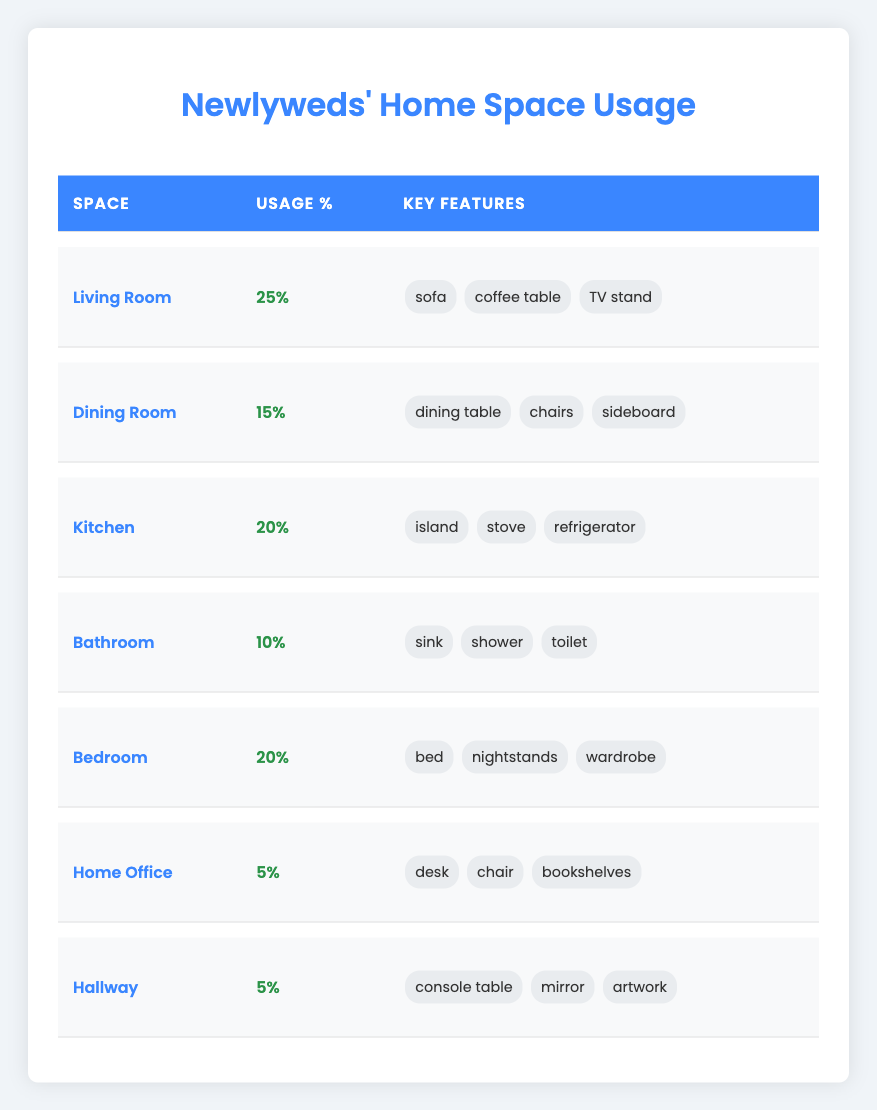What is the percentage of space usage in the Living Room? According to the table, the usage percentage for the Living Room is listed as 25%.
Answer: 25% Is the Dining Room space usage greater than the Home Office's? The Dining Room usage percentage is 15%, while the Home Office is only 5%. Since 15% is greater than 5%, the statement is true.
Answer: Yes What are the key features of the Bedroom? The table shows that the Bedroom includes key features such as a bed, nightstands, and a wardrobe.
Answer: Bed, nightstands, wardrobe What is the total percentage of space usage in common areas (Living Room, Dining Room, Kitchen) versus private spaces (Bedroom, Bathroom, Home Office)? The common areas usage is 25% + 15% + 20% = 60%. The private spaces usage is 20% + 10% + 5% = 35%. Comparing these totals, common areas usage is greater than private spaces.
Answer: Common areas: 60%, Private spaces: 35% Which room has the least space usage? By reviewing the percentages in the table, both the Home Office and Hallway have the lowest usage, each at 5%.
Answer: Home Office and Hallway If we combine the usage percentages of the Kitchen and Bathroom, what will that total be? The table shows the Kitchen at 20% and the Bathroom at 10%. Adding these together gives 20% + 10% = 30%.
Answer: 30% Is there any space with an exactly 20% usage percentage? The Bedroom and Kitchen both have a usage percentage of 20%. Therefore, the answer is yes.
Answer: Yes What is the percentage difference between the space usage of the Living Room and the Bathroom? The Living Room usage is 25% and the Bathroom is 10%. The difference is 25% - 10% = 15%.
Answer: 15% If you were to prioritize common spaces based on usage percentage, which three spaces would you focus on? The three common spaces with the highest usage percentages are the Living Room (25%), Kitchen (20%), and Dining Room (15%).
Answer: Living Room, Kitchen, Dining Room What is the total percentage usage across all spaces? By adding all the usage percentages: 25% + 15% + 20% + 10% + 20% + 5% + 5% = 100%.
Answer: 100% 